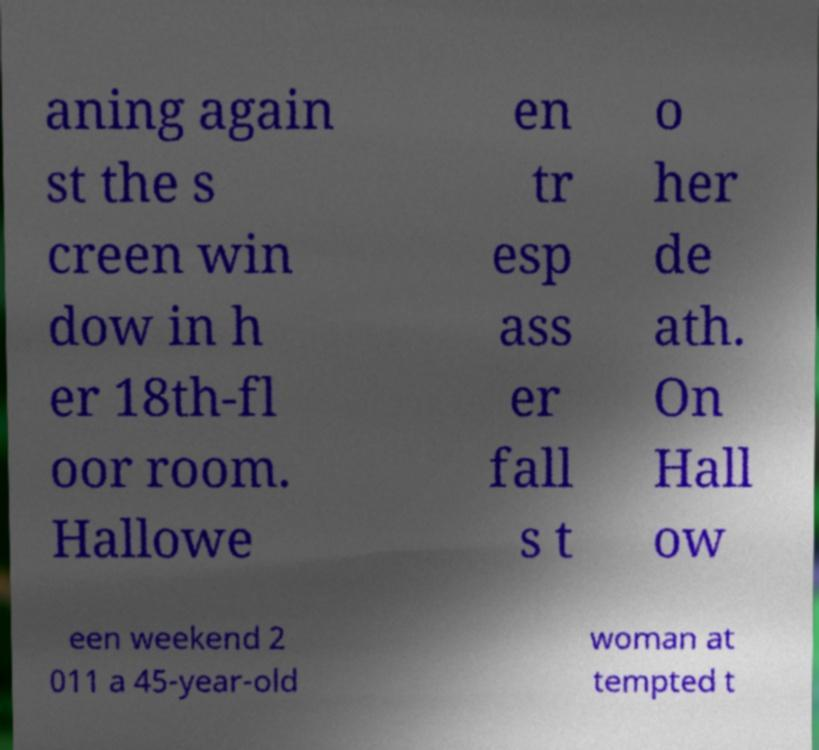Please read and relay the text visible in this image. What does it say? aning again st the s creen win dow in h er 18th-fl oor room. Hallowe en tr esp ass er fall s t o her de ath. On Hall ow een weekend 2 011 a 45-year-old woman at tempted t 